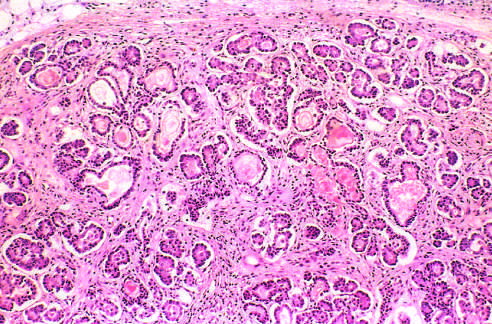re the necrotic cells atrophic and replaced by fibrous tissue?
Answer the question using a single word or phrase. No 